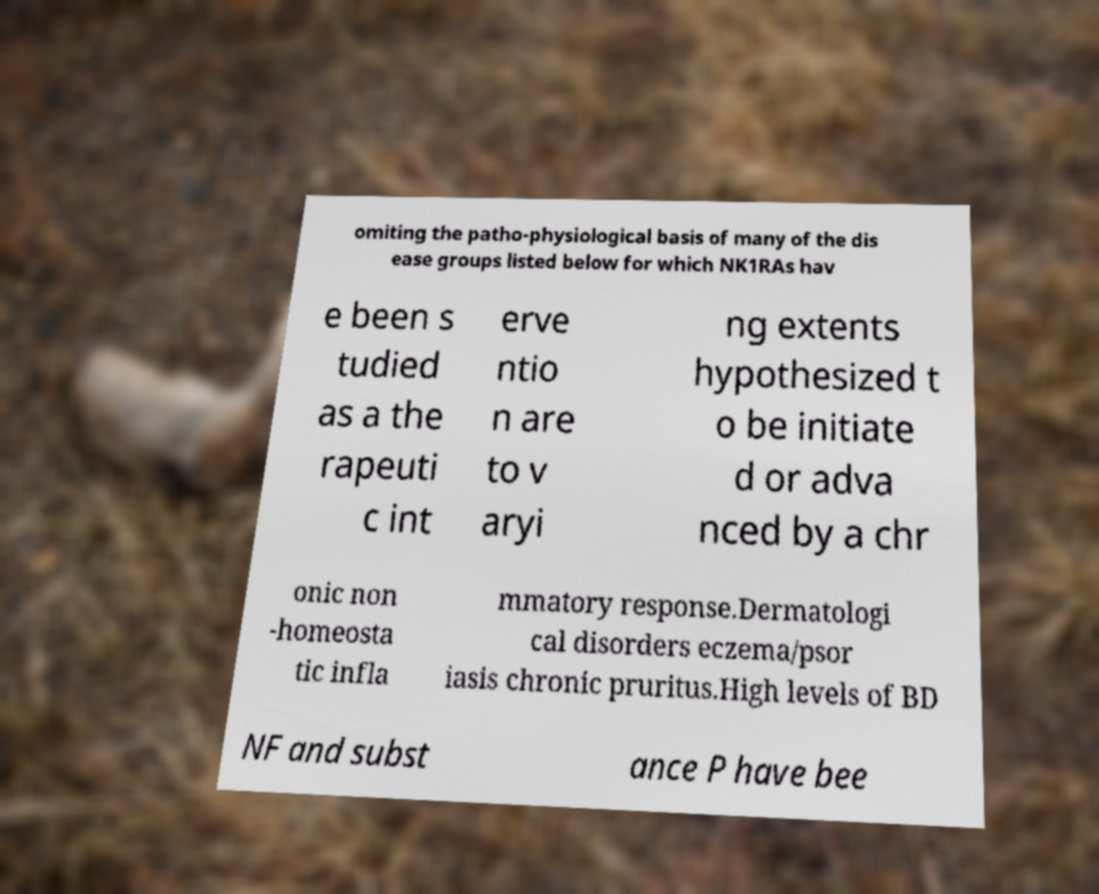There's text embedded in this image that I need extracted. Can you transcribe it verbatim? omiting the patho-physiological basis of many of the dis ease groups listed below for which NK1RAs hav e been s tudied as a the rapeuti c int erve ntio n are to v aryi ng extents hypothesized t o be initiate d or adva nced by a chr onic non -homeosta tic infla mmatory response.Dermatologi cal disorders eczema/psor iasis chronic pruritus.High levels of BD NF and subst ance P have bee 